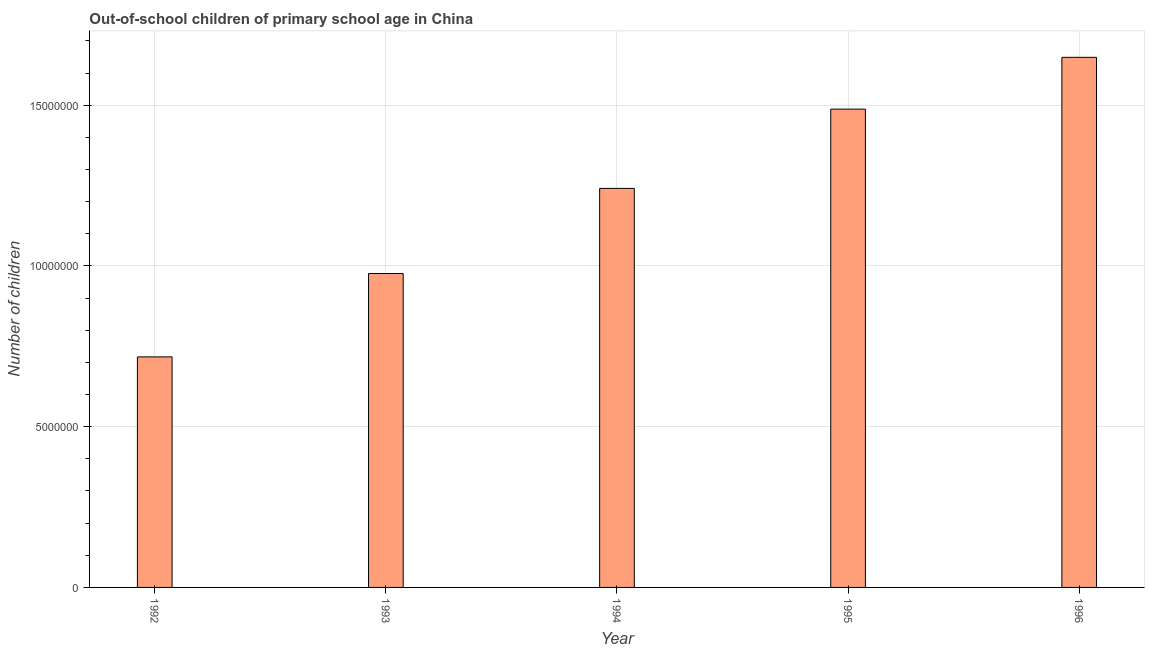What is the title of the graph?
Keep it short and to the point. Out-of-school children of primary school age in China. What is the label or title of the X-axis?
Your answer should be very brief. Year. What is the label or title of the Y-axis?
Your response must be concise. Number of children. What is the number of out-of-school children in 1993?
Provide a short and direct response. 9.76e+06. Across all years, what is the maximum number of out-of-school children?
Make the answer very short. 1.65e+07. Across all years, what is the minimum number of out-of-school children?
Your answer should be very brief. 7.17e+06. In which year was the number of out-of-school children maximum?
Your answer should be very brief. 1996. In which year was the number of out-of-school children minimum?
Offer a very short reply. 1992. What is the sum of the number of out-of-school children?
Ensure brevity in your answer.  6.07e+07. What is the difference between the number of out-of-school children in 1994 and 1996?
Ensure brevity in your answer.  -4.08e+06. What is the average number of out-of-school children per year?
Offer a terse response. 1.21e+07. What is the median number of out-of-school children?
Your answer should be very brief. 1.24e+07. In how many years, is the number of out-of-school children greater than 12000000 ?
Offer a terse response. 3. What is the ratio of the number of out-of-school children in 1994 to that in 1996?
Make the answer very short. 0.75. Is the number of out-of-school children in 1993 less than that in 1996?
Provide a succinct answer. Yes. What is the difference between the highest and the second highest number of out-of-school children?
Keep it short and to the point. 1.61e+06. What is the difference between the highest and the lowest number of out-of-school children?
Offer a terse response. 9.32e+06. Are the values on the major ticks of Y-axis written in scientific E-notation?
Keep it short and to the point. No. What is the Number of children in 1992?
Offer a terse response. 7.17e+06. What is the Number of children of 1993?
Offer a very short reply. 9.76e+06. What is the Number of children in 1994?
Your answer should be compact. 1.24e+07. What is the Number of children of 1995?
Your answer should be compact. 1.49e+07. What is the Number of children in 1996?
Offer a very short reply. 1.65e+07. What is the difference between the Number of children in 1992 and 1993?
Make the answer very short. -2.59e+06. What is the difference between the Number of children in 1992 and 1994?
Keep it short and to the point. -5.24e+06. What is the difference between the Number of children in 1992 and 1995?
Give a very brief answer. -7.71e+06. What is the difference between the Number of children in 1992 and 1996?
Your response must be concise. -9.32e+06. What is the difference between the Number of children in 1993 and 1994?
Your response must be concise. -2.65e+06. What is the difference between the Number of children in 1993 and 1995?
Your response must be concise. -5.11e+06. What is the difference between the Number of children in 1993 and 1996?
Offer a very short reply. -6.73e+06. What is the difference between the Number of children in 1994 and 1995?
Ensure brevity in your answer.  -2.47e+06. What is the difference between the Number of children in 1994 and 1996?
Keep it short and to the point. -4.08e+06. What is the difference between the Number of children in 1995 and 1996?
Make the answer very short. -1.61e+06. What is the ratio of the Number of children in 1992 to that in 1993?
Ensure brevity in your answer.  0.73. What is the ratio of the Number of children in 1992 to that in 1994?
Your answer should be very brief. 0.58. What is the ratio of the Number of children in 1992 to that in 1995?
Offer a terse response. 0.48. What is the ratio of the Number of children in 1992 to that in 1996?
Provide a succinct answer. 0.43. What is the ratio of the Number of children in 1993 to that in 1994?
Provide a succinct answer. 0.79. What is the ratio of the Number of children in 1993 to that in 1995?
Offer a terse response. 0.66. What is the ratio of the Number of children in 1993 to that in 1996?
Ensure brevity in your answer.  0.59. What is the ratio of the Number of children in 1994 to that in 1995?
Ensure brevity in your answer.  0.83. What is the ratio of the Number of children in 1994 to that in 1996?
Give a very brief answer. 0.75. What is the ratio of the Number of children in 1995 to that in 1996?
Your answer should be very brief. 0.9. 